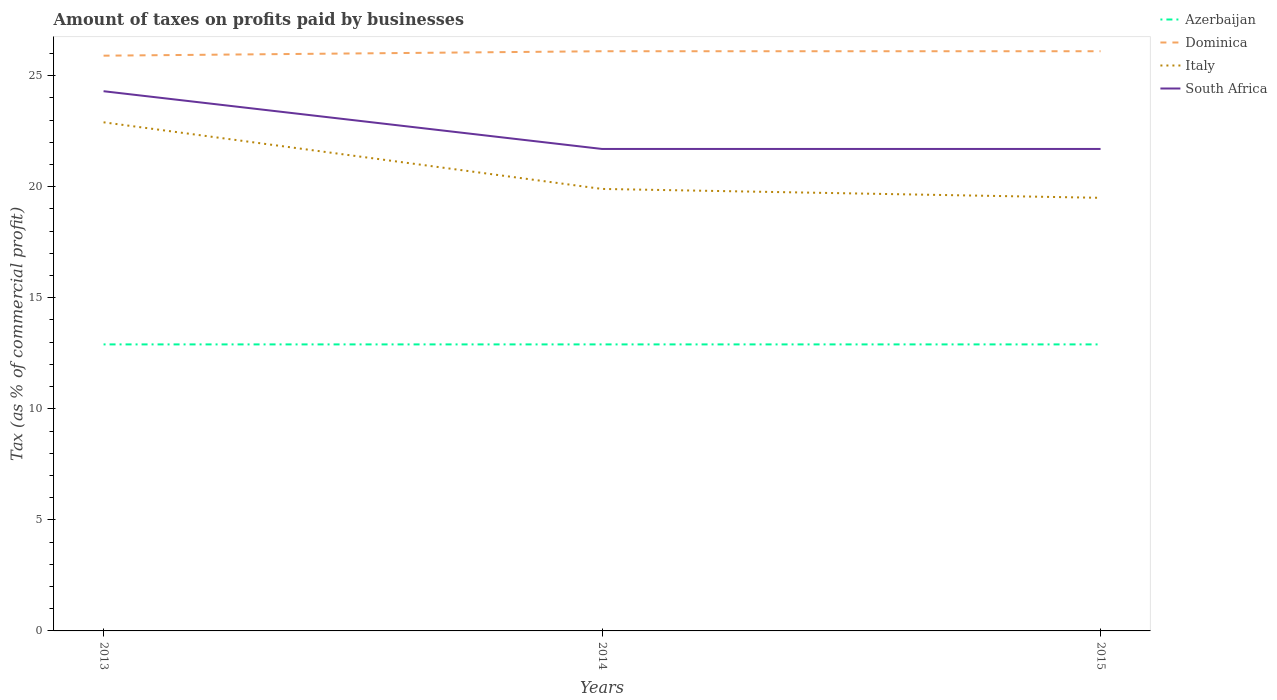Is the number of lines equal to the number of legend labels?
Make the answer very short. Yes. Across all years, what is the maximum percentage of taxes paid by businesses in Dominica?
Give a very brief answer. 25.9. What is the total percentage of taxes paid by businesses in Dominica in the graph?
Provide a short and direct response. -0.2. What is the difference between the highest and the second highest percentage of taxes paid by businesses in South Africa?
Provide a short and direct response. 2.6. Is the percentage of taxes paid by businesses in South Africa strictly greater than the percentage of taxes paid by businesses in Italy over the years?
Offer a very short reply. No. How many lines are there?
Your response must be concise. 4. What is the difference between two consecutive major ticks on the Y-axis?
Keep it short and to the point. 5. Are the values on the major ticks of Y-axis written in scientific E-notation?
Give a very brief answer. No. Does the graph contain any zero values?
Offer a very short reply. No. What is the title of the graph?
Keep it short and to the point. Amount of taxes on profits paid by businesses. What is the label or title of the Y-axis?
Offer a terse response. Tax (as % of commercial profit). What is the Tax (as % of commercial profit) in Azerbaijan in 2013?
Offer a very short reply. 12.9. What is the Tax (as % of commercial profit) of Dominica in 2013?
Keep it short and to the point. 25.9. What is the Tax (as % of commercial profit) of Italy in 2013?
Ensure brevity in your answer.  22.9. What is the Tax (as % of commercial profit) in South Africa in 2013?
Provide a succinct answer. 24.3. What is the Tax (as % of commercial profit) of Dominica in 2014?
Your answer should be very brief. 26.1. What is the Tax (as % of commercial profit) in Italy in 2014?
Provide a succinct answer. 19.9. What is the Tax (as % of commercial profit) of South Africa in 2014?
Offer a very short reply. 21.7. What is the Tax (as % of commercial profit) of Azerbaijan in 2015?
Your answer should be very brief. 12.9. What is the Tax (as % of commercial profit) in Dominica in 2015?
Ensure brevity in your answer.  26.1. What is the Tax (as % of commercial profit) of Italy in 2015?
Your response must be concise. 19.5. What is the Tax (as % of commercial profit) in South Africa in 2015?
Your answer should be compact. 21.7. Across all years, what is the maximum Tax (as % of commercial profit) in Dominica?
Keep it short and to the point. 26.1. Across all years, what is the maximum Tax (as % of commercial profit) in Italy?
Give a very brief answer. 22.9. Across all years, what is the maximum Tax (as % of commercial profit) of South Africa?
Provide a short and direct response. 24.3. Across all years, what is the minimum Tax (as % of commercial profit) of Dominica?
Make the answer very short. 25.9. Across all years, what is the minimum Tax (as % of commercial profit) of Italy?
Ensure brevity in your answer.  19.5. Across all years, what is the minimum Tax (as % of commercial profit) in South Africa?
Your response must be concise. 21.7. What is the total Tax (as % of commercial profit) in Azerbaijan in the graph?
Your answer should be very brief. 38.7. What is the total Tax (as % of commercial profit) of Dominica in the graph?
Ensure brevity in your answer.  78.1. What is the total Tax (as % of commercial profit) in Italy in the graph?
Offer a terse response. 62.3. What is the total Tax (as % of commercial profit) of South Africa in the graph?
Offer a terse response. 67.7. What is the difference between the Tax (as % of commercial profit) of Dominica in 2013 and that in 2014?
Give a very brief answer. -0.2. What is the difference between the Tax (as % of commercial profit) in Azerbaijan in 2013 and that in 2015?
Provide a short and direct response. 0. What is the difference between the Tax (as % of commercial profit) of Azerbaijan in 2013 and the Tax (as % of commercial profit) of Italy in 2014?
Ensure brevity in your answer.  -7. What is the difference between the Tax (as % of commercial profit) in Dominica in 2013 and the Tax (as % of commercial profit) in Italy in 2014?
Make the answer very short. 6. What is the difference between the Tax (as % of commercial profit) in Dominica in 2013 and the Tax (as % of commercial profit) in South Africa in 2014?
Keep it short and to the point. 4.2. What is the difference between the Tax (as % of commercial profit) of Italy in 2013 and the Tax (as % of commercial profit) of South Africa in 2014?
Keep it short and to the point. 1.2. What is the difference between the Tax (as % of commercial profit) in Azerbaijan in 2013 and the Tax (as % of commercial profit) in Dominica in 2015?
Offer a very short reply. -13.2. What is the difference between the Tax (as % of commercial profit) of Dominica in 2013 and the Tax (as % of commercial profit) of Italy in 2015?
Give a very brief answer. 6.4. What is the difference between the Tax (as % of commercial profit) in Italy in 2013 and the Tax (as % of commercial profit) in South Africa in 2015?
Ensure brevity in your answer.  1.2. What is the difference between the Tax (as % of commercial profit) in Azerbaijan in 2014 and the Tax (as % of commercial profit) in Dominica in 2015?
Offer a very short reply. -13.2. What is the difference between the Tax (as % of commercial profit) of Azerbaijan in 2014 and the Tax (as % of commercial profit) of Italy in 2015?
Provide a succinct answer. -6.6. What is the difference between the Tax (as % of commercial profit) in Azerbaijan in 2014 and the Tax (as % of commercial profit) in South Africa in 2015?
Keep it short and to the point. -8.8. What is the difference between the Tax (as % of commercial profit) in Italy in 2014 and the Tax (as % of commercial profit) in South Africa in 2015?
Your answer should be very brief. -1.8. What is the average Tax (as % of commercial profit) in Dominica per year?
Your answer should be very brief. 26.03. What is the average Tax (as % of commercial profit) in Italy per year?
Give a very brief answer. 20.77. What is the average Tax (as % of commercial profit) of South Africa per year?
Offer a terse response. 22.57. In the year 2013, what is the difference between the Tax (as % of commercial profit) of Azerbaijan and Tax (as % of commercial profit) of Italy?
Make the answer very short. -10. In the year 2013, what is the difference between the Tax (as % of commercial profit) in Azerbaijan and Tax (as % of commercial profit) in South Africa?
Offer a very short reply. -11.4. In the year 2013, what is the difference between the Tax (as % of commercial profit) in Dominica and Tax (as % of commercial profit) in Italy?
Provide a succinct answer. 3. In the year 2013, what is the difference between the Tax (as % of commercial profit) of Italy and Tax (as % of commercial profit) of South Africa?
Give a very brief answer. -1.4. In the year 2014, what is the difference between the Tax (as % of commercial profit) in Azerbaijan and Tax (as % of commercial profit) in South Africa?
Your answer should be very brief. -8.8. In the year 2014, what is the difference between the Tax (as % of commercial profit) in Dominica and Tax (as % of commercial profit) in Italy?
Offer a terse response. 6.2. In the year 2015, what is the difference between the Tax (as % of commercial profit) of Azerbaijan and Tax (as % of commercial profit) of Dominica?
Offer a very short reply. -13.2. In the year 2015, what is the difference between the Tax (as % of commercial profit) of Azerbaijan and Tax (as % of commercial profit) of South Africa?
Give a very brief answer. -8.8. What is the ratio of the Tax (as % of commercial profit) of Italy in 2013 to that in 2014?
Keep it short and to the point. 1.15. What is the ratio of the Tax (as % of commercial profit) of South Africa in 2013 to that in 2014?
Give a very brief answer. 1.12. What is the ratio of the Tax (as % of commercial profit) of Italy in 2013 to that in 2015?
Provide a succinct answer. 1.17. What is the ratio of the Tax (as % of commercial profit) in South Africa in 2013 to that in 2015?
Provide a succinct answer. 1.12. What is the ratio of the Tax (as % of commercial profit) of Azerbaijan in 2014 to that in 2015?
Ensure brevity in your answer.  1. What is the ratio of the Tax (as % of commercial profit) in Dominica in 2014 to that in 2015?
Keep it short and to the point. 1. What is the ratio of the Tax (as % of commercial profit) in Italy in 2014 to that in 2015?
Your response must be concise. 1.02. What is the difference between the highest and the second highest Tax (as % of commercial profit) of Azerbaijan?
Provide a short and direct response. 0. What is the difference between the highest and the second highest Tax (as % of commercial profit) of Dominica?
Keep it short and to the point. 0. What is the difference between the highest and the second highest Tax (as % of commercial profit) of Italy?
Give a very brief answer. 3. What is the difference between the highest and the lowest Tax (as % of commercial profit) of South Africa?
Provide a short and direct response. 2.6. 